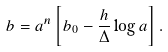<formula> <loc_0><loc_0><loc_500><loc_500>b = a ^ { n } \left [ b _ { 0 } - \frac { h } { \Delta } \log a \right ] .</formula> 